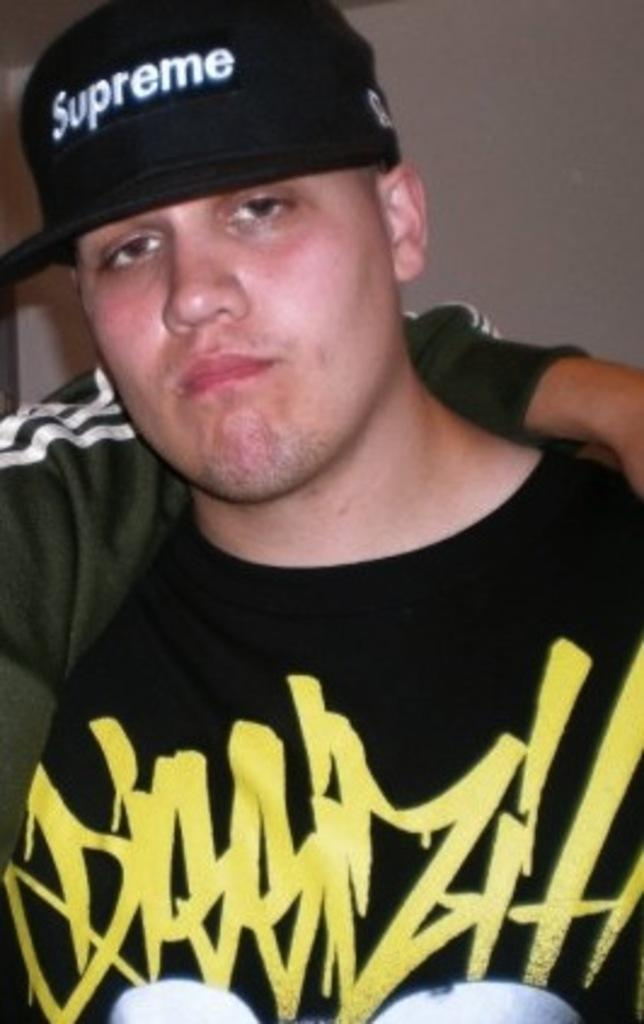<image>
Render a clear and concise summary of the photo. man with unhappy expression on his face wearing a black cap with supreme on it 